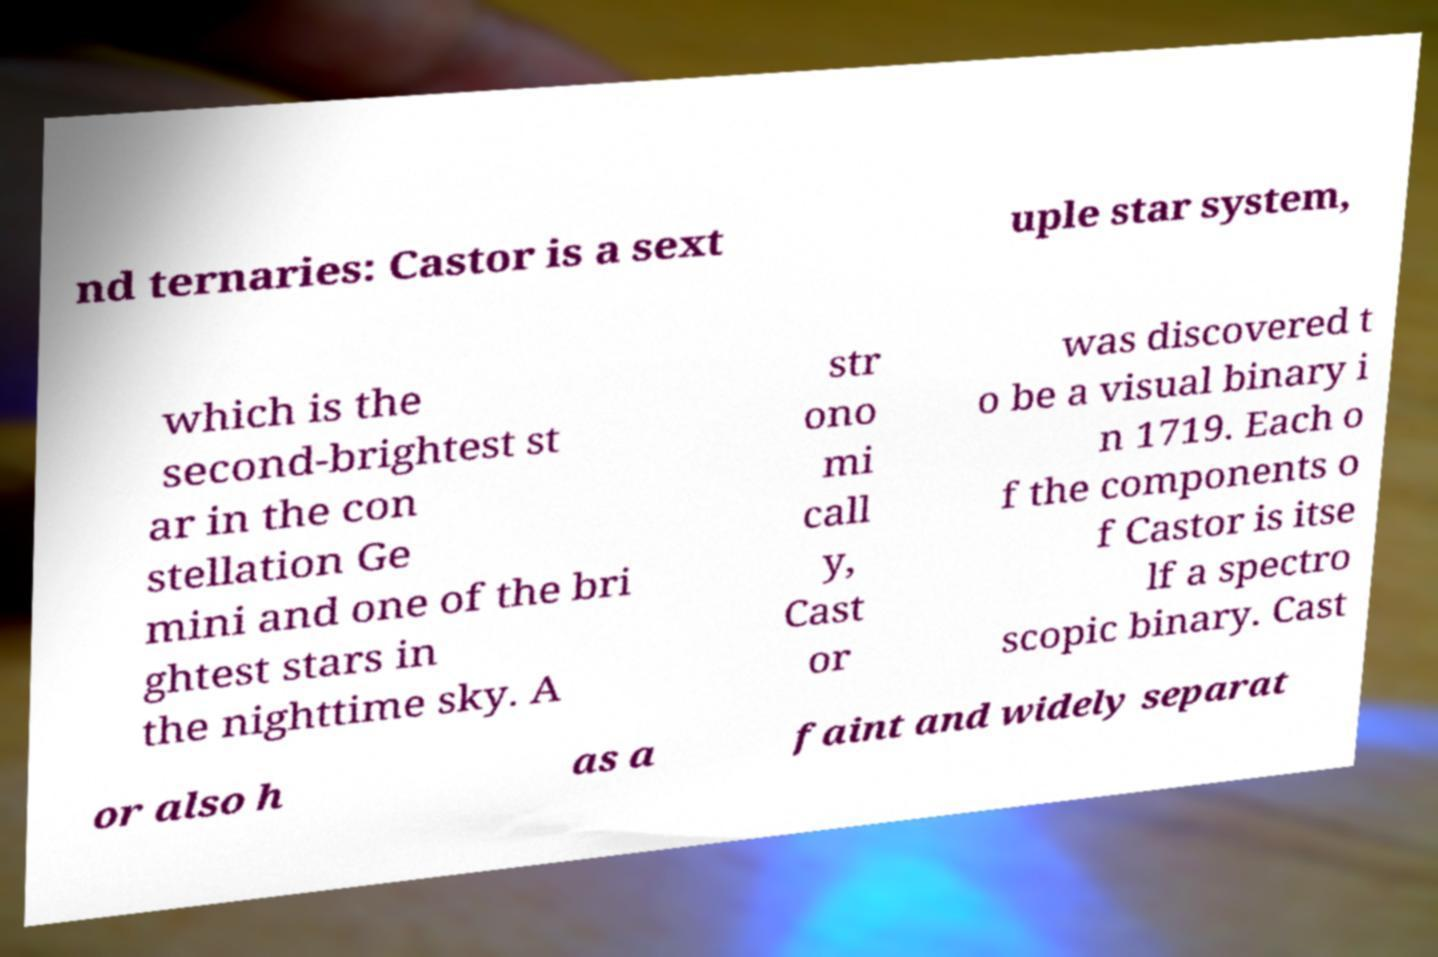I need the written content from this picture converted into text. Can you do that? nd ternaries: Castor is a sext uple star system, which is the second-brightest st ar in the con stellation Ge mini and one of the bri ghtest stars in the nighttime sky. A str ono mi call y, Cast or was discovered t o be a visual binary i n 1719. Each o f the components o f Castor is itse lf a spectro scopic binary. Cast or also h as a faint and widely separat 